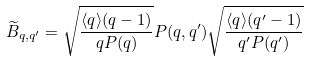<formula> <loc_0><loc_0><loc_500><loc_500>\widetilde { B } _ { q , q ^ { \prime } } = \sqrt { \frac { \langle q \rangle ( q - 1 ) } { q P ( q ) } } P ( q , q ^ { \prime } ) \sqrt { \frac { \langle q \rangle ( q ^ { \prime } - 1 ) } { q ^ { \prime } P ( q ^ { \prime } ) } }</formula> 